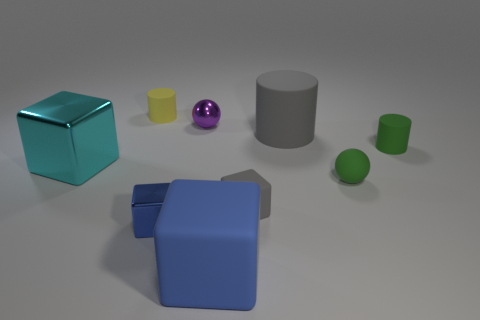Subtract all green blocks. Subtract all gray cylinders. How many blocks are left? 4 Add 1 large blue things. How many objects exist? 10 Subtract all cylinders. How many objects are left? 6 Add 2 large gray rubber things. How many large gray rubber things are left? 3 Add 1 blue metallic objects. How many blue metallic objects exist? 2 Subtract 1 gray cubes. How many objects are left? 8 Subtract all green shiny cubes. Subtract all blocks. How many objects are left? 5 